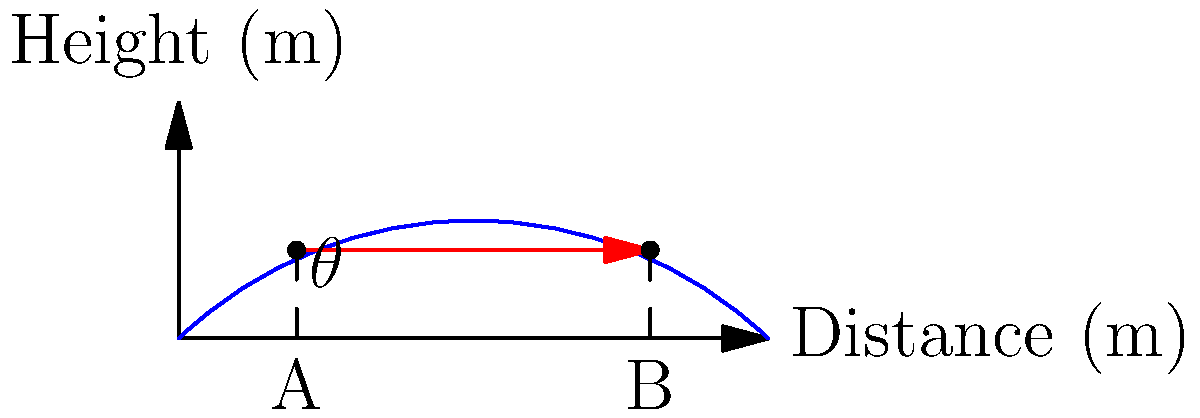At the 1997 Rally Australia, you witnessed an exciting jump where a rally car needed to clear a hill. The car launches from point A and needs to land at point B, both at a height of 15 meters. The horizontal distance between A and B is 60 meters. What is the optimal launch angle $\theta$ (in degrees) for the car to make this jump, assuming it maintains a constant speed and neglecting air resistance? Let's approach this step-by-step:

1) In projectile motion, the optimal angle for maximum range is 45°. However, since both the launch and landing points are at the same height, we can use a formula derived from the range equation.

2) The formula for the optimal angle in this case is:
   $$\theta = \frac{1}{2} \arcsin(\frac{g x}{v^2})$$
   where $g$ is the acceleration due to gravity, $x$ is the horizontal distance, and $v$ is the initial velocity.

3) We know $x = 60$ meters and $g = 9.8$ m/s². We need to find $v$.

4) We can use the equation for the time of flight:
   $$t = \frac{2v \sin\theta}{g}$$

5) And the equation for horizontal distance:
   $$x = v \cos\theta \cdot t$$

6) Substituting the time equation into the distance equation:
   $$x = v \cos\theta \cdot \frac{2v \sin\theta}{g}$$

7) This simplifies to:
   $$x = \frac{v^2 \sin(2\theta)}{g}$$

8) For the optimal angle, $\sin(2\theta) = 1$, so:
   $$60 = \frac{v^2}{9.8}$$

9) Solving for $v$:
   $$v = \sqrt{60 \cdot 9.8} \approx 24.25 m/s$$

10) Now we can use the optimal angle formula:
    $$\theta = \frac{1}{2} \arcsin(\frac{9.8 \cdot 60}{24.25^2})$$

11) Calculating:
    $$\theta = \frac{1}{2} \arcsin(1) = \frac{1}{2} \cdot 90° = 45°$$

Therefore, the optimal launch angle is 45°.
Answer: 45° 